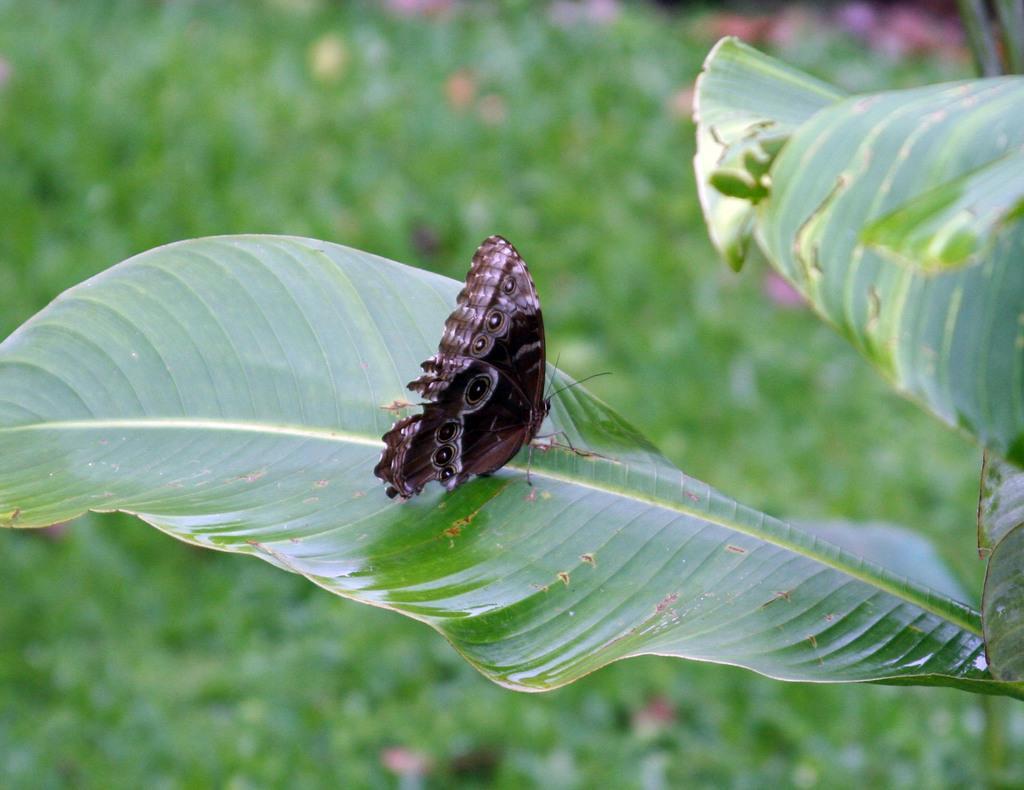Could you give a brief overview of what you see in this image? In this picture we can observe a butterfly which is in brown and white color on the green color leaf. In the background there are some plants on the ground. 